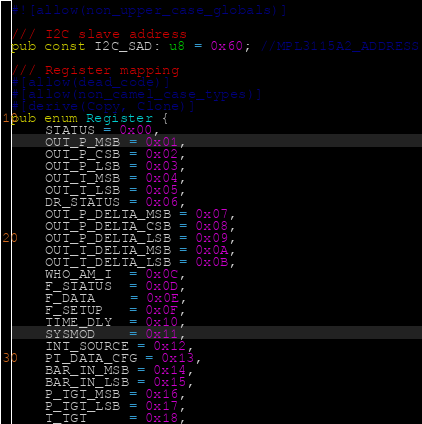<code> <loc_0><loc_0><loc_500><loc_500><_Rust_>#![allow(non_upper_case_globals)]

/// I2C slave address
pub const I2C_SAD: u8 = 0x60; //MPL3115A2_ADDRESS

/// Register mapping
#[allow(dead_code)]
#[allow(non_camel_case_types)]
#[derive(Copy, Clone)]
pub enum Register {
    STATUS = 0x00,
    OUT_P_MSB = 0x01,
    OUT_P_CSB = 0x02,
    OUT_P_LSB = 0x03,
    OUT_T_MSB = 0x04,
    OUT_T_LSB = 0x05,
    DR_STATUS = 0x06,
    OUT_P_DELTA_MSB = 0x07,
    OUT_P_DELTA_CSB = 0x08,
    OUT_P_DELTA_LSB = 0x09,
    OUT_T_DELTA_MSB = 0x0A,
    OUT_T_DELTA_LSB = 0x0B,
    WHO_AM_I  = 0x0C,
    F_STATUS  = 0x0D,
    F_DATA    = 0x0E,
    F_SETUP   = 0x0F,
    TIME_DLY  = 0x10,
    SYSMOD    = 0x11,
    INT_SOURCE = 0x12,
    PT_DATA_CFG = 0x13,
    BAR_IN_MSB = 0x14,
    BAR_IN_LSB = 0x15,
    P_TGT_MSB = 0x16,
    P_TGT_LSB = 0x17,
    T_TGT     = 0x18,</code> 